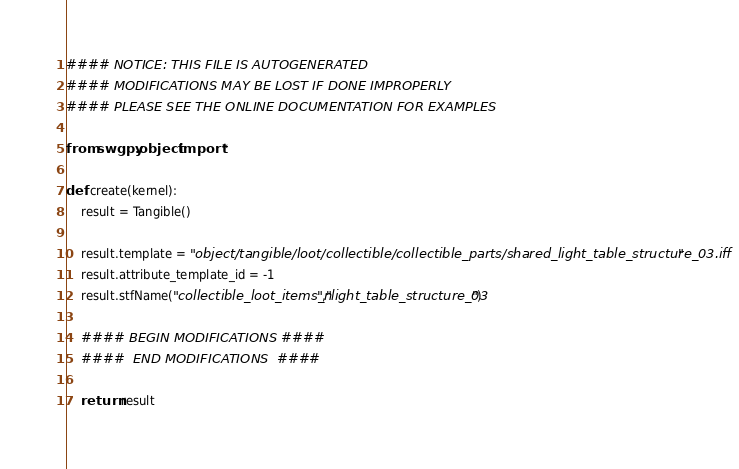Convert code to text. <code><loc_0><loc_0><loc_500><loc_500><_Python_>#### NOTICE: THIS FILE IS AUTOGENERATED
#### MODIFICATIONS MAY BE LOST IF DONE IMPROPERLY
#### PLEASE SEE THE ONLINE DOCUMENTATION FOR EXAMPLES

from swgpy.object import *	

def create(kernel):
	result = Tangible()

	result.template = "object/tangible/loot/collectible/collectible_parts/shared_light_table_structure_03.iff"
	result.attribute_template_id = -1
	result.stfName("collectible_loot_items_n","light_table_structure_03")		
	
	#### BEGIN MODIFICATIONS ####
	####  END MODIFICATIONS  ####
	
	return result</code> 